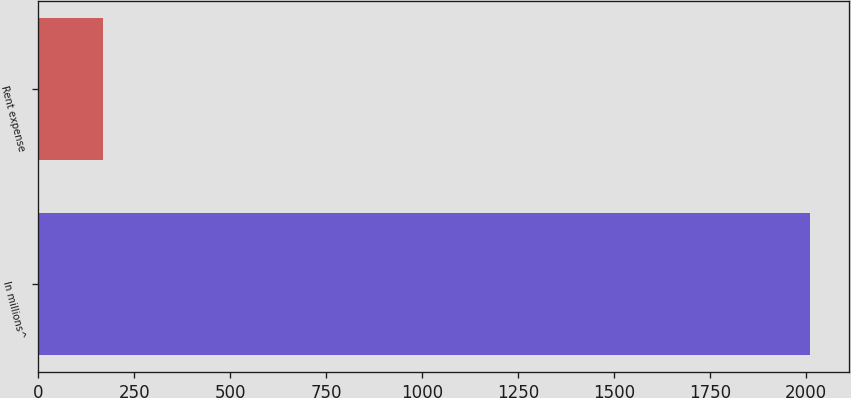Convert chart. <chart><loc_0><loc_0><loc_500><loc_500><bar_chart><fcel>In millions^<fcel>Rent expense<nl><fcel>2011<fcel>169<nl></chart> 